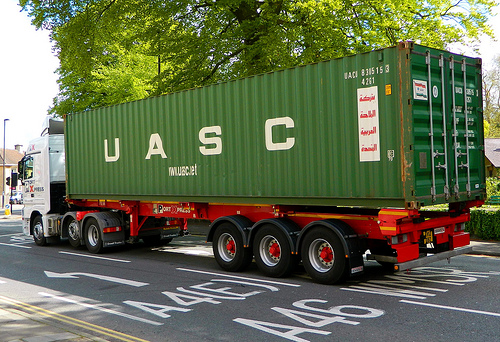Which kind of vehicle is green? The green vehicle in the picture is a truck. 